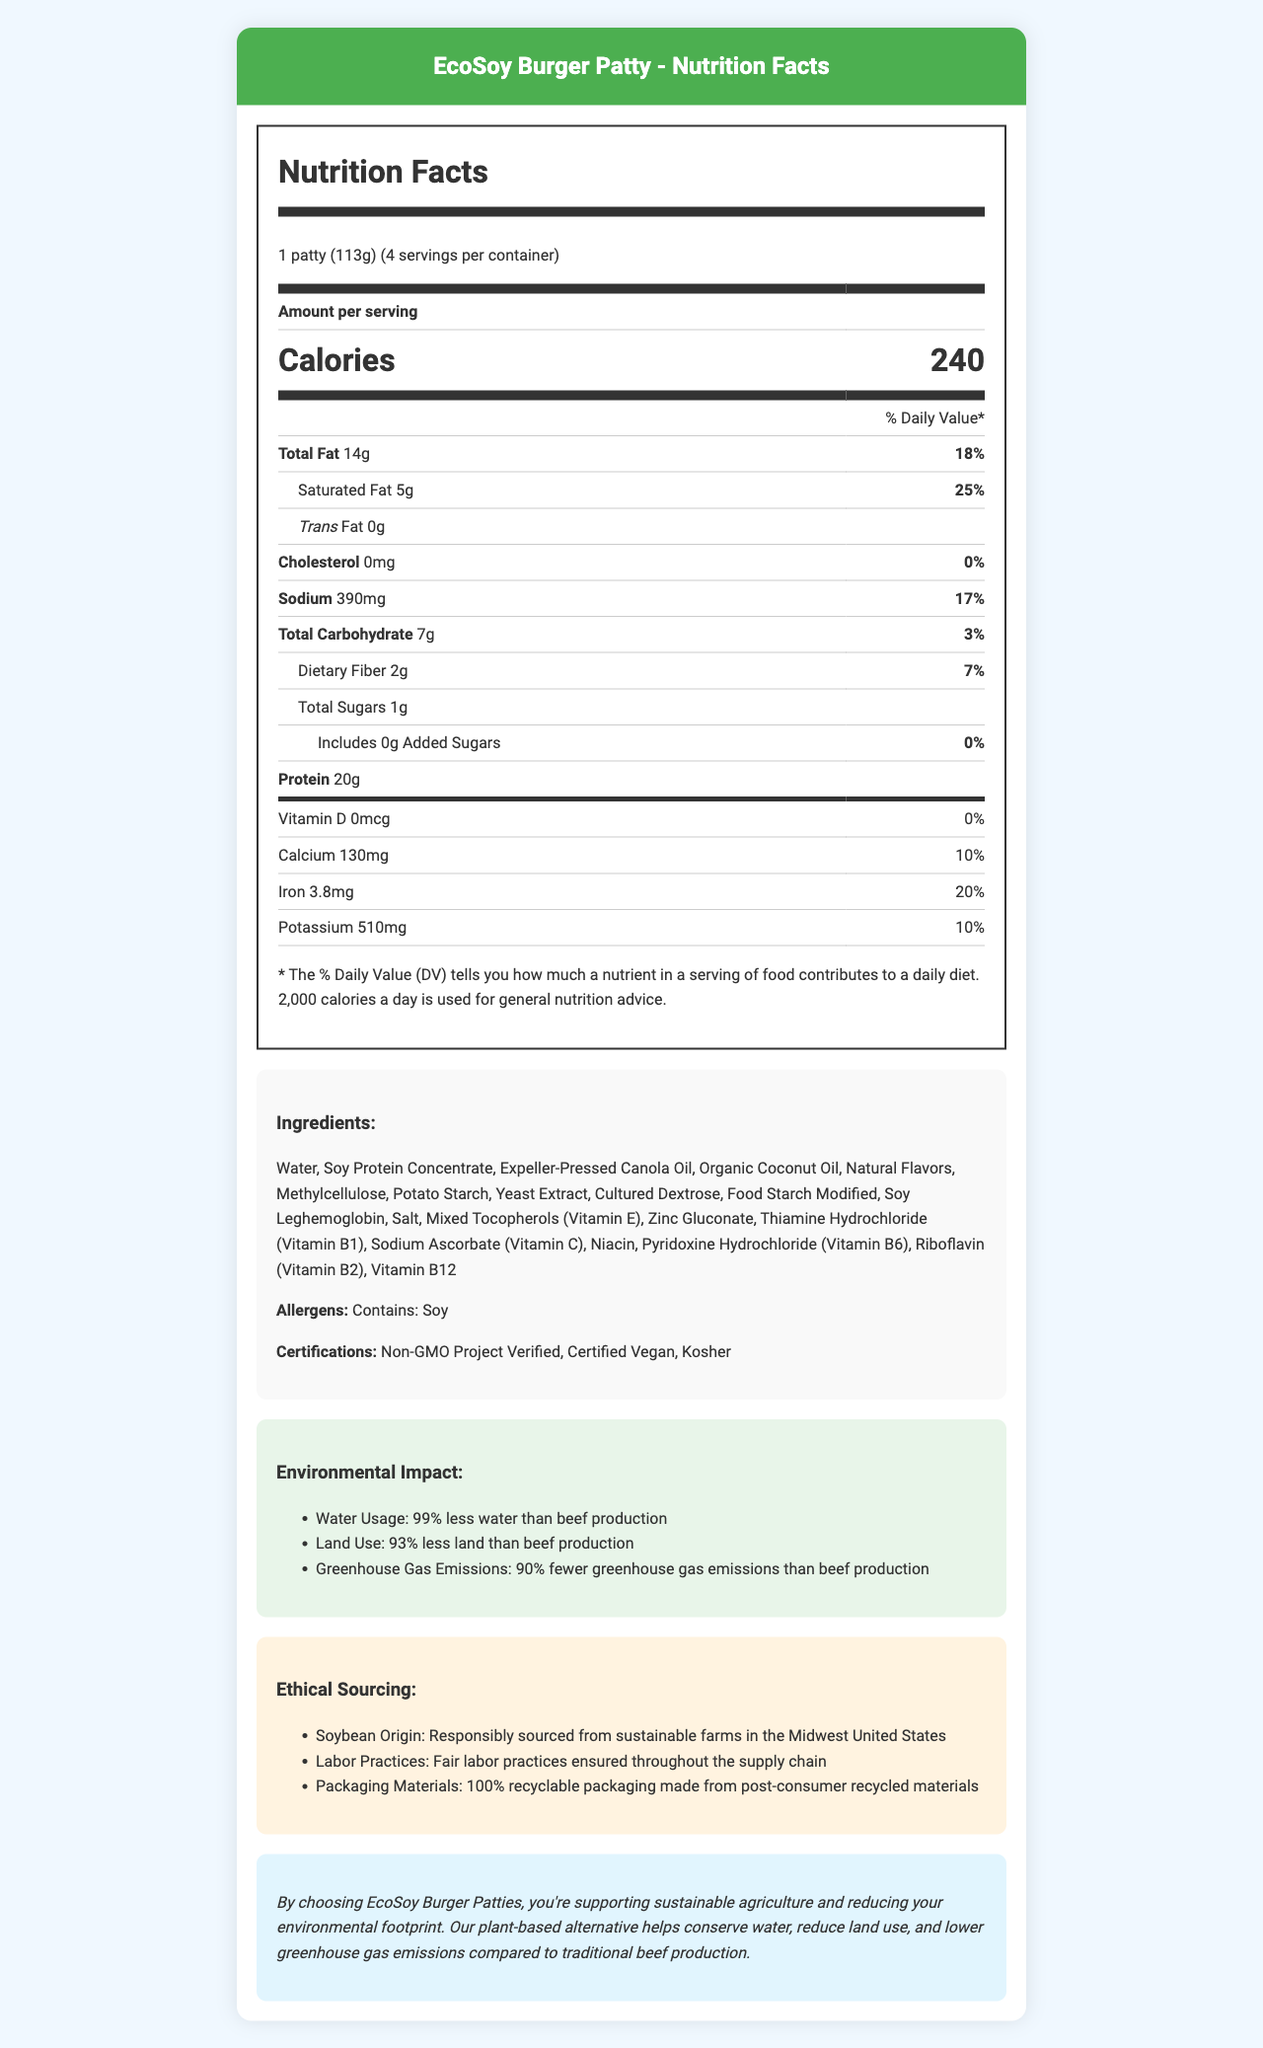what is the serving size for the EcoSoy Burger Patty? The serving size is listed as "1 patty (113g)" in the nutrition label.
Answer: 1 patty (113g) how many servings are there per container? This information is directly stated as "servings per container: 4."
Answer: 4 how many grams of protein are in one serving? The nutrition label indicates that there are 20 grams of protein per serving.
Answer: 20g what ingredients does the EcoSoy Burger Patty contain? The ingredients are listed under the "Ingredients" section of the document.
Answer: Water, Soy Protein Concentrate, Expeller-Pressed Canola Oil, Organic Coconut Oil, Natural Flavors, Methylcellulose, Potato Starch, Yeast Extract, Cultured Dextrose, Food Starch Modified, Soy Leghemoglobin, Salt, Mixed Tocopherols (Vitamin E), Zinc Gluconate, Thiamine Hydrochloride (Vitamin B1), Sodium Ascorbate (Vitamin C), Niacin, Pyridoxine Hydrochloride (Vitamin B6), Riboflavin (Vitamin B2), Vitamin B12 what makes the packaging of the EcoSoy Burger Patty environmentally friendly? This information is found under the "ethical sourcing" section where it mentions that the packaging materials are "100% recyclable packaging made from post-consumer recycled materials."
Answer: 100% recyclable packaging made from post-consumer recycled materials how much fat is in one serving of the EcoSoy Burger Patty?
A. 5g
B. 14g
C. 18g
D. 20g The nutrition label states that the total fat per serving is 14g.
Answer: B which of the following certifications does the EcoSoy Burger Patty NOT have?
1. Non-GMO Project Verified
2. Certified Organic
3. Certified Vegan
4. Kosher The document lists the certifications as "Non-GMO Project Verified", "Certified Vegan", and "Kosher". It does not mention "Certified Organic."
Answer: 2 does the EcoSoy Burger Patty contain any added sugars? The nutrition label indicates "Includes 0g Added Sugars".
Answer: No what sustainability efforts are mentioned for the EcoSoy Burger Patty? The sustainability statement at the end of the document mentions these efforts.
Answer: The product supports sustainable agriculture, conserves water, reduces land use, and lowers greenhouse gas emissions compared to traditional beef production. describe the nutritional and ethical aspects of the EcoSoy Burger Patty. The nutritional information is found in the "Nutrition Facts" section. The ethical aspects are detailed in the sections on "Ethical Sourcing" and the "Sustainability Statement."
Answer: The EcoSoy Burger Patty has 240 calories per serving, with 14g of total fat, 20g of protein, and no cholesterol. It contains soy as an allergen and is certified Non-GMO, Vegan, and Kosher. Environmentally, it uses 99% less water, 93% less land, and emits 90% fewer greenhouse gases than beef production. Ethically, it uses responsibly sourced soybeans, fair labor practices, and 100% recyclable packaging. where does the soybean ingredient in the EcoSoy Burger Patty come from? This information is listed under the "ethical sourcing" section regarding the origin of the soybeans.
Answer: Responsibly sourced from sustainable farms in the Midwest United States why is the EcoSoy Burger Patty a more environmentally friendly alternative compared to beef? This information is highlighted in the "Environmental Impact" section.
Answer: It uses 99% less water, 93% less land, and produces 90% fewer greenhouse gas emissions. what is the total carbohydrate content in one serving of the EcoSoy Burger Patty? The total carbohydrate content per serving is listed in the nutrition label.
Answer: 7g what is the percentage of daily value for iron in one serving of the EcoSoy Burger Patty? The nutrition label indicates that the % Daily Value for iron is 20%.
Answer: 20% what is the origin of the canola oil used in the EcoSoy Burger Patty? The document does not provide information about the origin of the canola oil.
Answer: Cannot be determined 